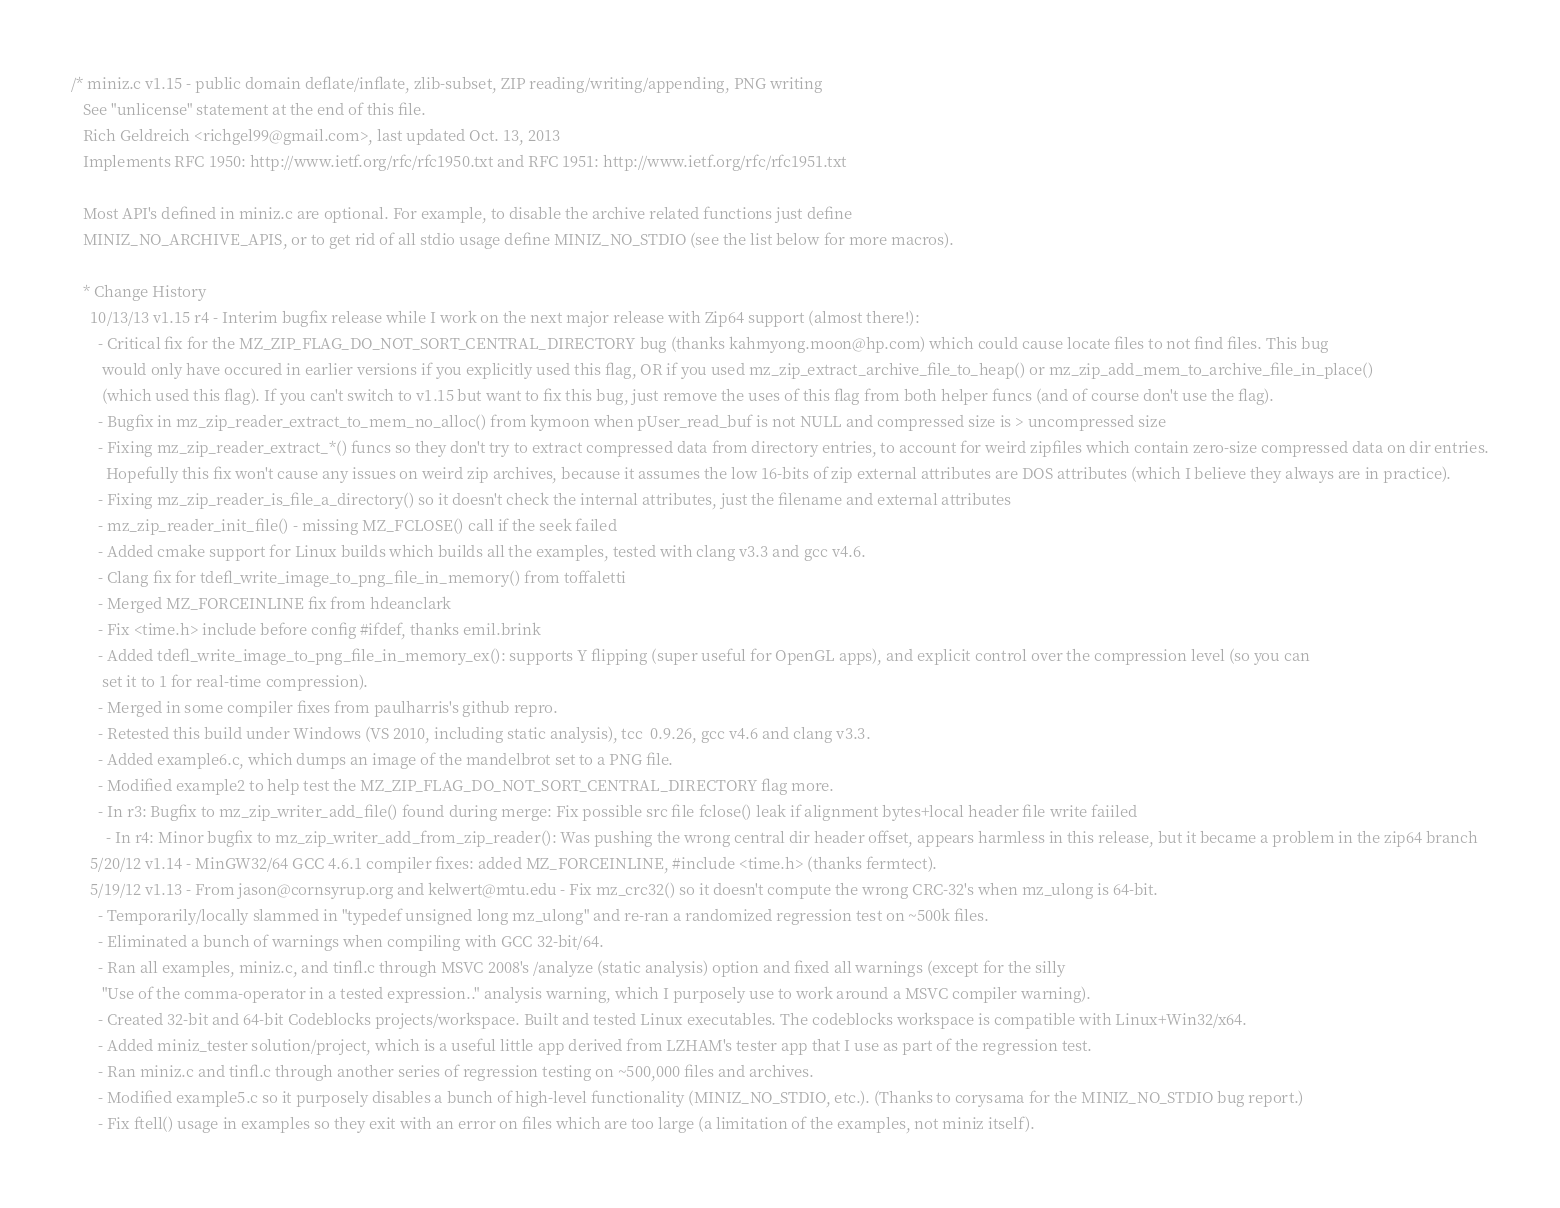Convert code to text. <code><loc_0><loc_0><loc_500><loc_500><_C_>/* miniz.c v1.15 - public domain deflate/inflate, zlib-subset, ZIP reading/writing/appending, PNG writing
   See "unlicense" statement at the end of this file.
   Rich Geldreich <richgel99@gmail.com>, last updated Oct. 13, 2013
   Implements RFC 1950: http://www.ietf.org/rfc/rfc1950.txt and RFC 1951: http://www.ietf.org/rfc/rfc1951.txt

   Most API's defined in miniz.c are optional. For example, to disable the archive related functions just define
   MINIZ_NO_ARCHIVE_APIS, or to get rid of all stdio usage define MINIZ_NO_STDIO (see the list below for more macros).

   * Change History
     10/13/13 v1.15 r4 - Interim bugfix release while I work on the next major release with Zip64 support (almost there!):
       - Critical fix for the MZ_ZIP_FLAG_DO_NOT_SORT_CENTRAL_DIRECTORY bug (thanks kahmyong.moon@hp.com) which could cause locate files to not find files. This bug
        would only have occured in earlier versions if you explicitly used this flag, OR if you used mz_zip_extract_archive_file_to_heap() or mz_zip_add_mem_to_archive_file_in_place()
        (which used this flag). If you can't switch to v1.15 but want to fix this bug, just remove the uses of this flag from both helper funcs (and of course don't use the flag).
       - Bugfix in mz_zip_reader_extract_to_mem_no_alloc() from kymoon when pUser_read_buf is not NULL and compressed size is > uncompressed size
       - Fixing mz_zip_reader_extract_*() funcs so they don't try to extract compressed data from directory entries, to account for weird zipfiles which contain zero-size compressed data on dir entries.
         Hopefully this fix won't cause any issues on weird zip archives, because it assumes the low 16-bits of zip external attributes are DOS attributes (which I believe they always are in practice).
       - Fixing mz_zip_reader_is_file_a_directory() so it doesn't check the internal attributes, just the filename and external attributes
       - mz_zip_reader_init_file() - missing MZ_FCLOSE() call if the seek failed
       - Added cmake support for Linux builds which builds all the examples, tested with clang v3.3 and gcc v4.6.
       - Clang fix for tdefl_write_image_to_png_file_in_memory() from toffaletti
       - Merged MZ_FORCEINLINE fix from hdeanclark
       - Fix <time.h> include before config #ifdef, thanks emil.brink
       - Added tdefl_write_image_to_png_file_in_memory_ex(): supports Y flipping (super useful for OpenGL apps), and explicit control over the compression level (so you can
        set it to 1 for real-time compression).
       - Merged in some compiler fixes from paulharris's github repro.
       - Retested this build under Windows (VS 2010, including static analysis), tcc  0.9.26, gcc v4.6 and clang v3.3.
       - Added example6.c, which dumps an image of the mandelbrot set to a PNG file.
       - Modified example2 to help test the MZ_ZIP_FLAG_DO_NOT_SORT_CENTRAL_DIRECTORY flag more.
       - In r3: Bugfix to mz_zip_writer_add_file() found during merge: Fix possible src file fclose() leak if alignment bytes+local header file write faiiled
		 - In r4: Minor bugfix to mz_zip_writer_add_from_zip_reader(): Was pushing the wrong central dir header offset, appears harmless in this release, but it became a problem in the zip64 branch
     5/20/12 v1.14 - MinGW32/64 GCC 4.6.1 compiler fixes: added MZ_FORCEINLINE, #include <time.h> (thanks fermtect).
     5/19/12 v1.13 - From jason@cornsyrup.org and kelwert@mtu.edu - Fix mz_crc32() so it doesn't compute the wrong CRC-32's when mz_ulong is 64-bit.
       - Temporarily/locally slammed in "typedef unsigned long mz_ulong" and re-ran a randomized regression test on ~500k files.
       - Eliminated a bunch of warnings when compiling with GCC 32-bit/64.
       - Ran all examples, miniz.c, and tinfl.c through MSVC 2008's /analyze (static analysis) option and fixed all warnings (except for the silly
        "Use of the comma-operator in a tested expression.." analysis warning, which I purposely use to work around a MSVC compiler warning).
       - Created 32-bit and 64-bit Codeblocks projects/workspace. Built and tested Linux executables. The codeblocks workspace is compatible with Linux+Win32/x64.
       - Added miniz_tester solution/project, which is a useful little app derived from LZHAM's tester app that I use as part of the regression test.
       - Ran miniz.c and tinfl.c through another series of regression testing on ~500,000 files and archives.
       - Modified example5.c so it purposely disables a bunch of high-level functionality (MINIZ_NO_STDIO, etc.). (Thanks to corysama for the MINIZ_NO_STDIO bug report.)
       - Fix ftell() usage in examples so they exit with an error on files which are too large (a limitation of the examples, not miniz itself).</code> 